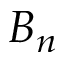Convert formula to latex. <formula><loc_0><loc_0><loc_500><loc_500>B _ { n }</formula> 